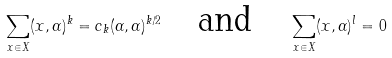Convert formula to latex. <formula><loc_0><loc_0><loc_500><loc_500>\sum _ { x \in X } ( x , \alpha ) ^ { k } = c _ { k } ( \alpha , \alpha ) ^ { k / 2 } \quad \text {and} \quad \sum _ { x \in X } ( x , \alpha ) ^ { l } = 0</formula> 